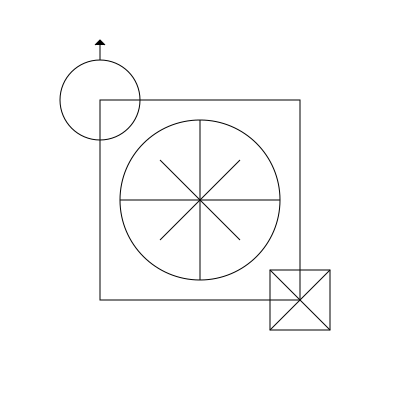In this spatial rotation task, identify which feminist symbol would result if the Venus symbol (♀) in the top-left corner is rotated 180 degrees around its center point. Consider the other symbols shown: the equality sign (=) in the center and the raised fist (☭) in the bottom-right corner. To solve this problem, we need to mentally rotate the Venus symbol (♀) 180 degrees around its center point. Let's break it down step-by-step:

1. Observe the Venus symbol (♀) in the top-left corner. It consists of a circle with a small cross below it.

2. Imagine rotating this symbol 180 degrees clockwise or counterclockwise around its center point.

3. After rotation:
   - The circle part would remain unchanged due to its symmetry.
   - The cross part, which was originally at the bottom, would now be at the top.

4. The resulting shape after rotation would be a circle with a small cross above it.

5. Compare this mentally rotated shape with the other symbols shown:
   - The equality sign (=) in the center doesn't match.
   - The raised fist (☭) in the bottom-right corner doesn't match.

6. The rotated Venus symbol now resembles the Mars symbol (♂), which represents the male gender in biology and is often used in contrast to the Venus symbol in feminist discourse.

Therefore, the 180-degree rotation of the Venus symbol results in a shape that looks like the Mars symbol (♂), although this symbol is not explicitly shown in the given image.
Answer: Mars symbol (♂) 